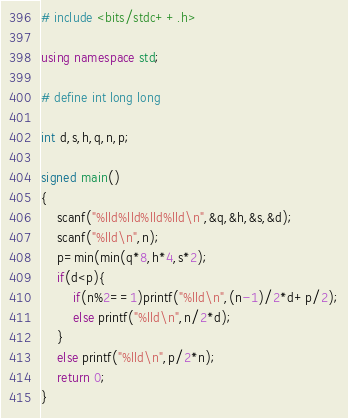<code> <loc_0><loc_0><loc_500><loc_500><_C++_># include <bits/stdc++.h>

using namespace std;

# define int long long

int d,s,h,q,n,p;

signed main()
{
 	scanf("%lld%lld%lld%lld\n",&q,&h,&s,&d);
  	scanf("%lld\n",n);
  	p=min(min(q*8,h*4,s*2);
  	if(d<p){
     	if(n%2==1)printf("%lld\n",(n-1)/2*d+p/2);
      	else printf("%lld\n",n/2*d);
    }
    else printf("%lld\n",p/2*n);
    return 0;
}</code> 